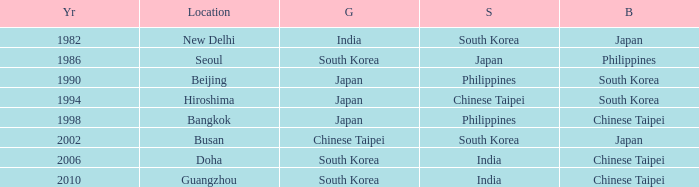Which Year is the highest one that has a Bronze of south korea, and a Silver of philippines? 1990.0. 